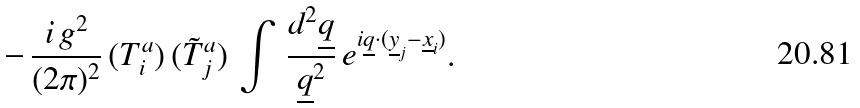<formula> <loc_0><loc_0><loc_500><loc_500>- \, \frac { i \, g ^ { 2 } } { ( 2 \pi ) ^ { 2 } } \, ( T ^ { a } _ { i } ) \, ( \tilde { T } ^ { a } _ { j } ) \, \int \, \frac { d ^ { 2 } { \underline { q } } } { { \underline { q } } ^ { 2 } } \, e ^ { i { \underline { q } } \cdot ( { \underline { y } } _ { j } - { \underline { x } } _ { i } ) } .</formula> 